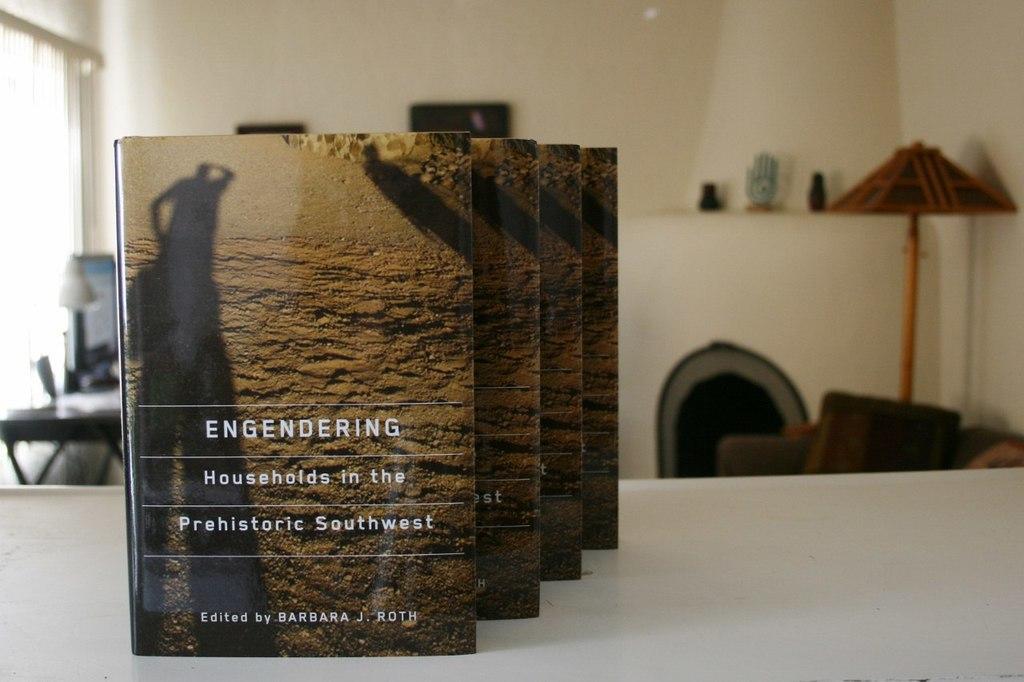Describe this image in one or two sentences. We can see books on the table. In the background we can see monitor and objects on the table, wall and there are few things. 